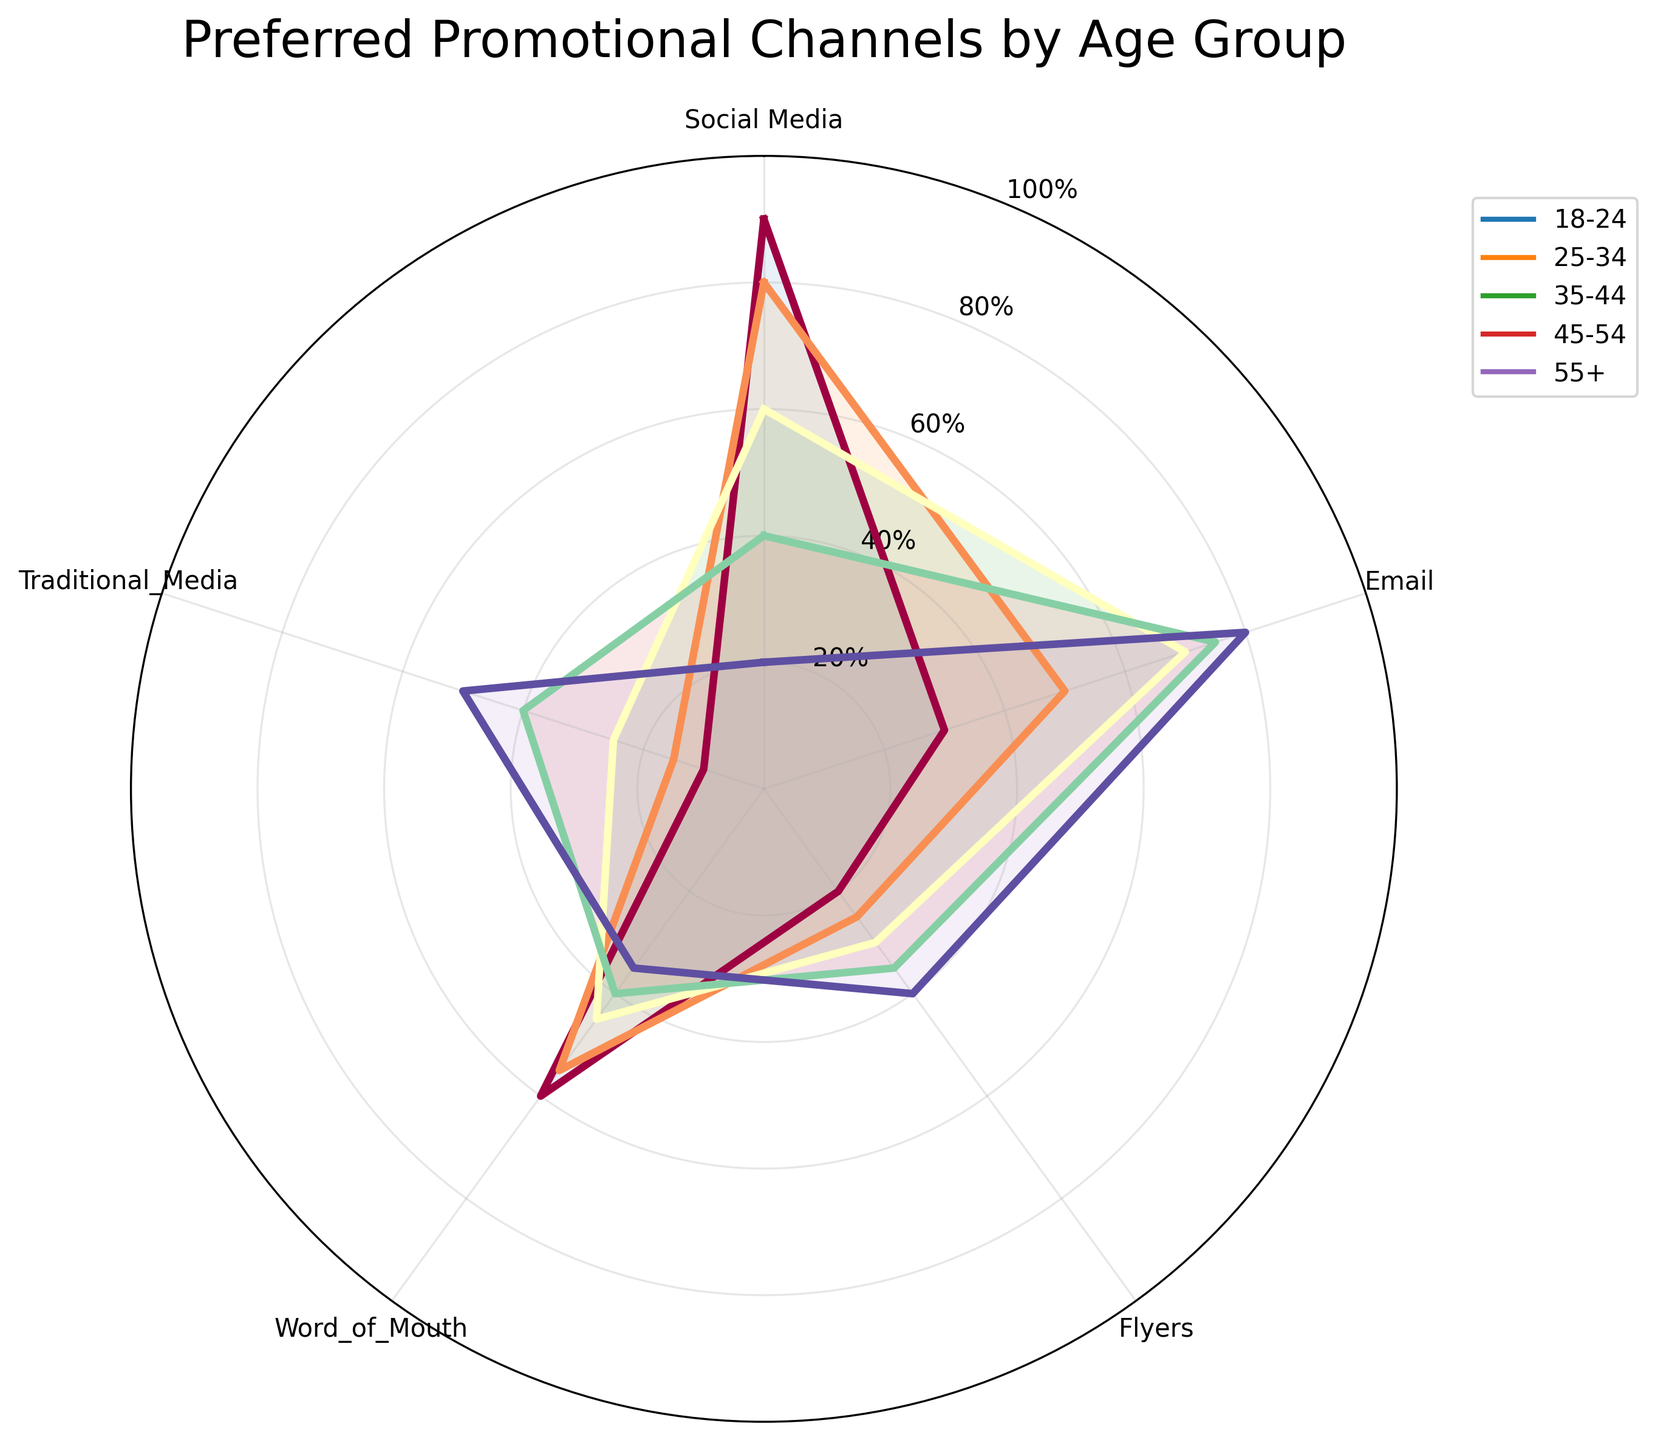How many age groups are depicted in the figure? By observing the legend or the data lines in the radar chart, there are 5 different age groups marked: 18-24, 25-34, 35-44, 45-54, and 55+.
Answer: 5 Which promotional channel is preferred most by the 18-24 age group? Looking at the radar plot for the 18-24 age group, the highest value is at 'Social Media', with a preference percentage of 90%.
Answer: Social Media How does the preference for 'Traditional Media' change as the age group increases? Observing the radar chart, 'Traditional Media' preference values increase from 10% for 18-24 to 50% for 55+. The percentages ascend as follows: 10, 15, 25, 40, 50.
Answer: Increases What is the combined preference for 'Flyers' and 'Email' for the 35-44 age group? According to the radar chart, the 35-44 age group prefers 'Flyers' at 30% and 'Email' at 70%. The combined preference is 30% + 70% = 100%.
Answer: 100% For which age group is 'Word of Mouth' least preferred, and what is the percentage? By checking the radar chart, the 'Word of Mouth' value is lowest at 35% for the 55+ age group.
Answer: 55+ Which age group values 'Email' the most? Considering the email preference on the radar chart, the highest value (80%) is shown by the 55+ age group.
Answer: 55+ Is there an age group that prefers 'Flyers' more than 'Social Media'? Referring to the radar chart, no age group has a higher value for 'Flyers' compared to 'Social Media'. All higher preferences are for 'Social Media' over 'Flyers'.
Answer: No Compare the difference in preference for 'Social Media' between the 18-24 and 35-44 age groups. The radar chart shows that the 18-24 age group values 'Social Media' at 90%, while the 35-44 age group values it at 60%. The difference is 90% - 60% = 30%.
Answer: 30% Which promotional channel shows the largest increase in preference from the 25-34 age group to the 45-54 age group? Observing the radar chart, 'Traditional Media' preference increases from 15% in the 25-34 age group to 40% in the 45-54 age group, the largest increase of 25%.
Answer: Traditional Media Does any age group prefer 'Word of Mouth' more than 'Email'? By comparing the radar chart values for 'Email' and 'Word of Mouth', none of the age groups have a higher value for 'Word of Mouth' compared to 'Email'.
Answer: No 